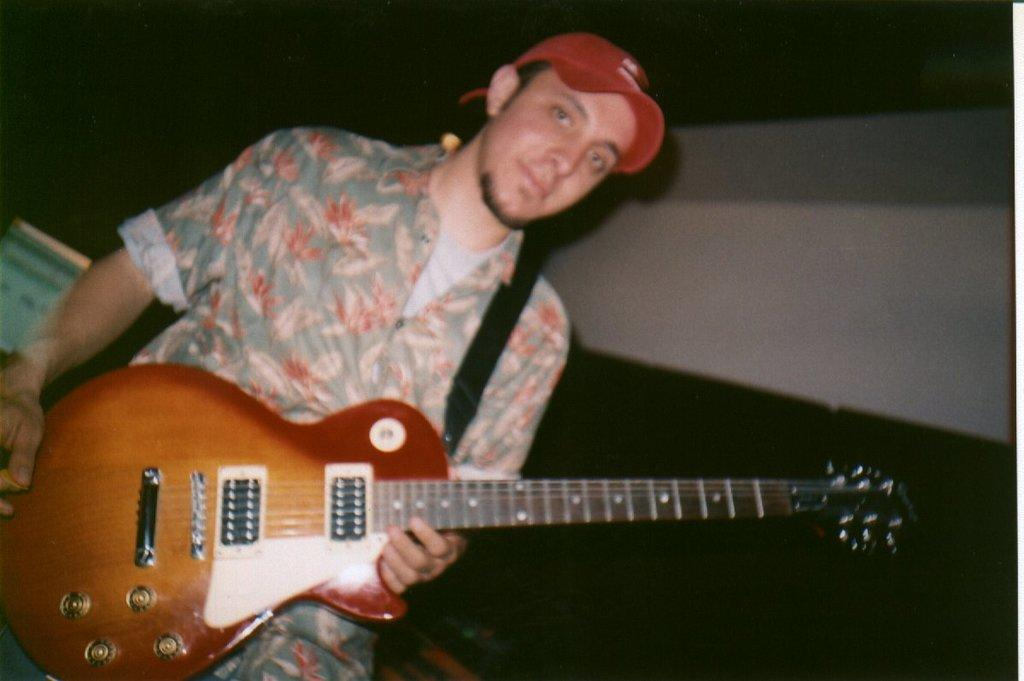What is the main subject of the image? The main subject of the image is a man. What is the man wearing in the image? The man is wearing a shirt in the image. What object is the man holding in the image? The man is holding a guitar in the image. What type of headwear is the man wearing in the image? The man is wearing a red color cap on his head in the image. What type of wall can be seen behind the man in the image? There is no wall visible in the image; it only shows the man, his clothing, and the guitar he is holding. 